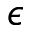<formula> <loc_0><loc_0><loc_500><loc_500>\epsilon</formula> 